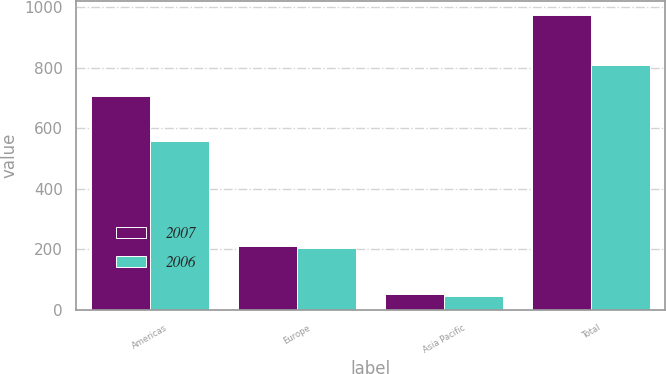Convert chart to OTSL. <chart><loc_0><loc_0><loc_500><loc_500><stacked_bar_chart><ecel><fcel>Americas<fcel>Europe<fcel>Asia Pacific<fcel>Total<nl><fcel>2007<fcel>707.3<fcel>211.8<fcel>52.8<fcel>971.9<nl><fcel>2006<fcel>558.5<fcel>203.6<fcel>45<fcel>807.1<nl></chart> 